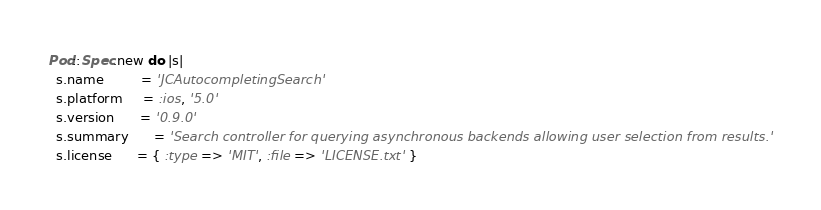Convert code to text. <code><loc_0><loc_0><loc_500><loc_500><_Ruby_>Pod::Spec.new do |s|
  s.name         = 'JCAutocompletingSearch'
  s.platform     = :ios, '5.0'
  s.version      = '0.9.0'
  s.summary      = 'Search controller for querying asynchronous backends allowing user selection from results.'
  s.license      = { :type => 'MIT', :file => 'LICENSE.txt' }</code> 